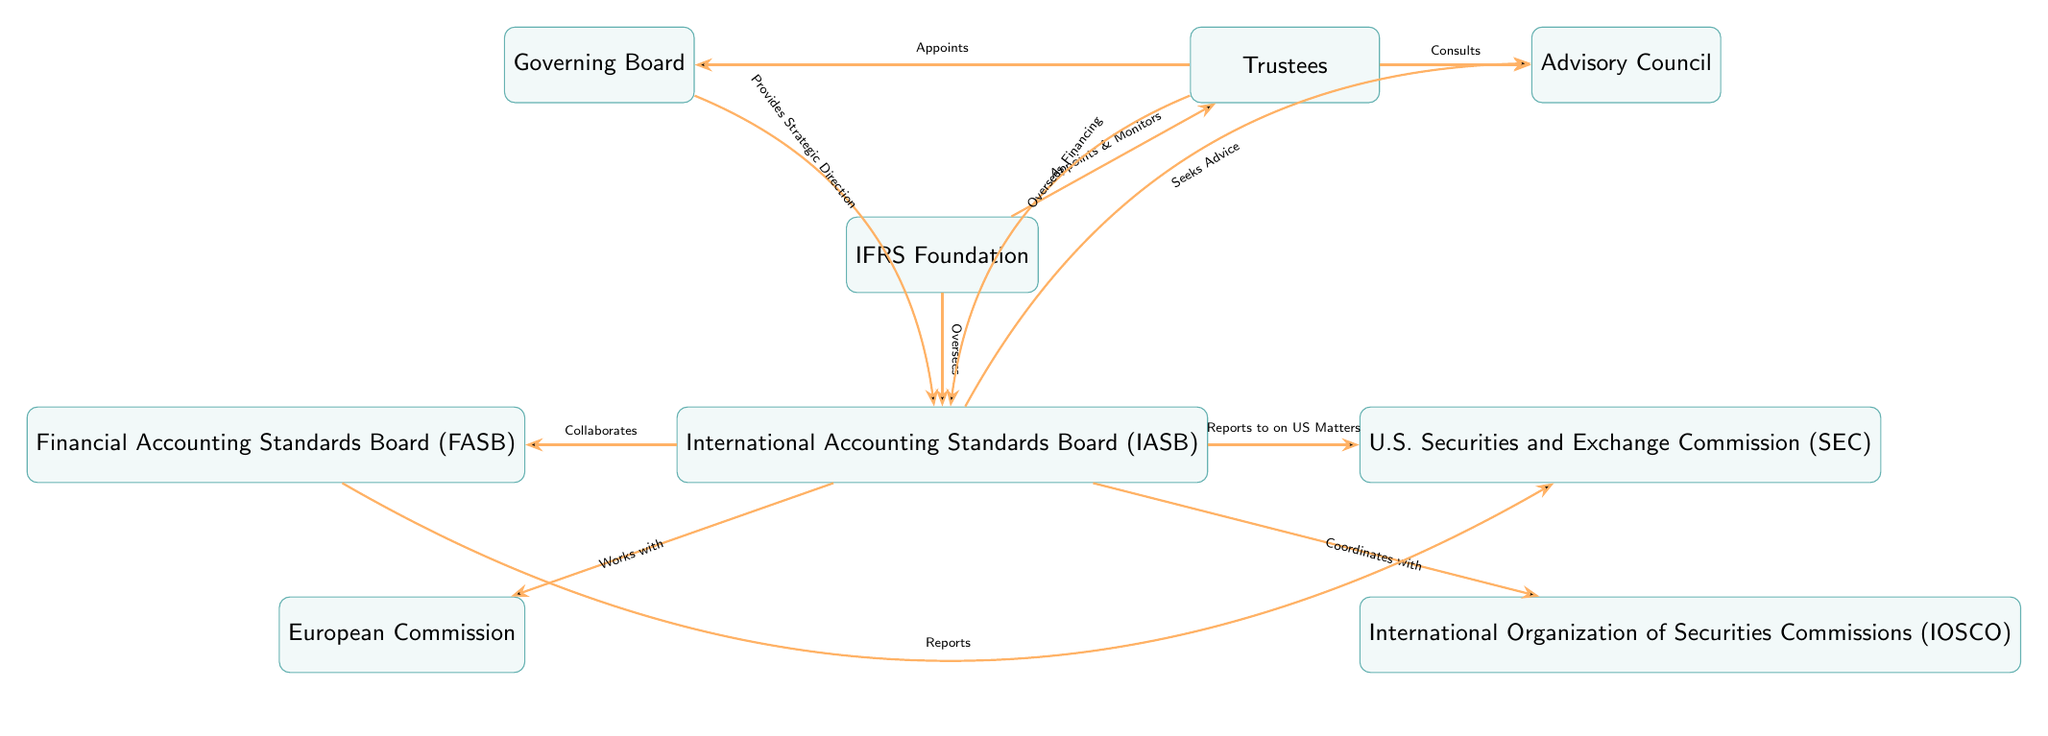What is the main governing body of the IFRS Foundation? The diagram indicates that the main governing body of the IFRS Foundation is the "Governing Board," which is positioned above the IFRS Foundation node.
Answer: Governing Board How many entities are directly connected to the IASB? The IASB node is connected to four other entities: FASB, SEC, EU, and IOSCO. Counting these connections gives a total of four entities directly connected to the IASB.
Answer: 4 What role does the Trustees (T) have concerning the IASB? The diagram shows that the Trustees (T) "Oversees Financing" for the IASB, indicating their supervisory role in financial matters related to the IASB.
Answer: Oversees Financing Which organization does the IASB report to regarding U.S. Matters? The line connecting the IASB to the SEC indicates that the IASB "Reports to on US Matters," clarifying that the SEC is the organization involved.
Answer: SEC What is the relationship between the IASB and the FASB? According to the diagram, the IASB "Collaborates" with the FASB, suggesting a cooperative relationship between these two organizations in financial reporting standards.
Answer: Collaborates How does the Advisory Council (AC) interact with the Trustees (T)? The diagram indicates that the Trustees (T) "Consults" with the Advisory Council (AC). This indicates a formal interaction where the Trustees seek advice or information from the Council.
Answer: Consults Which entity is responsible for providing strategic direction to the IASB? The diagram specifies that the "Governing Board" provides "Strategic Direction" to the IASB, establishing its role in guiding the IASB's activities.
Answer: Provides Strategic Direction What is the purpose of the connection between IASB and IOSCO? The diagram states that the IASB "Coordinates with" IOSCO, suggesting that their connection revolves around collaboration and aligning standards or practices within the global financial community.
Answer: Coordinates with Name one external body that the IASB collaborates with. The diagram shows a direct connection between the IASB and the FASB indicating collaboration, providing one of the external bodies.
Answer: FASB 